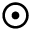Convert formula to latex. <formula><loc_0><loc_0><loc_500><loc_500>\odot</formula> 